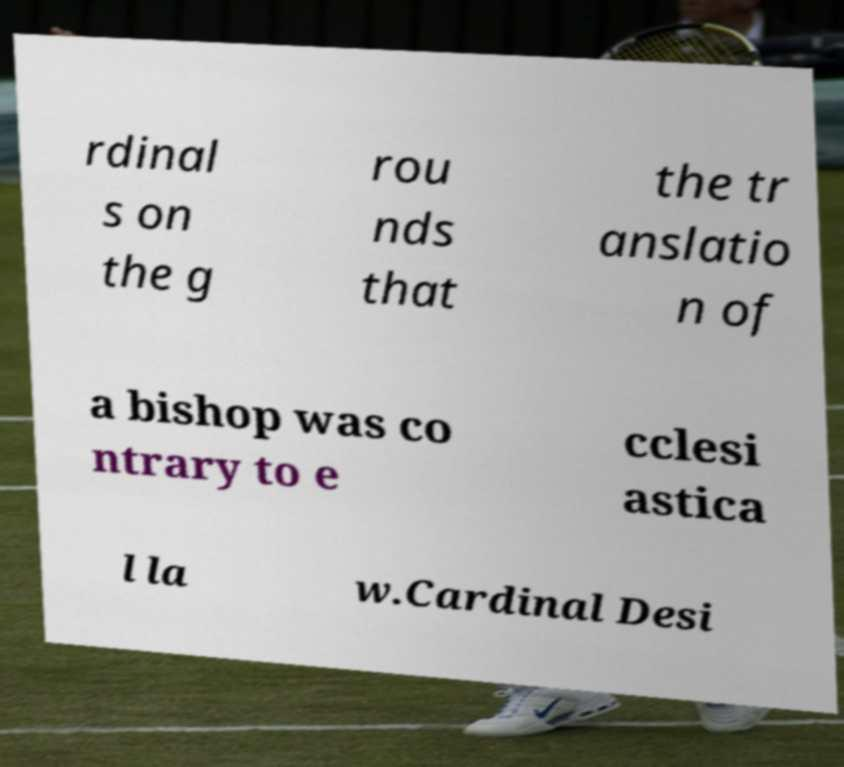For documentation purposes, I need the text within this image transcribed. Could you provide that? rdinal s on the g rou nds that the tr anslatio n of a bishop was co ntrary to e cclesi astica l la w.Cardinal Desi 